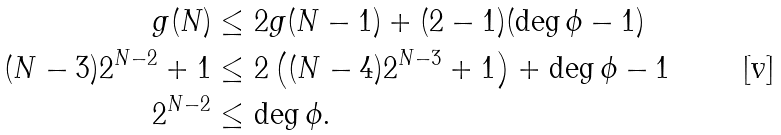<formula> <loc_0><loc_0><loc_500><loc_500>g ( N ) & \leq 2 g ( N - 1 ) + ( 2 - 1 ) ( \deg \phi - 1 ) \\ ( N - 3 ) 2 ^ { N - 2 } + 1 & \leq 2 \left ( ( N - 4 ) 2 ^ { N - 3 } + 1 \right ) + \deg \phi - 1 \\ 2 ^ { N - 2 } & \leq \deg \phi .</formula> 